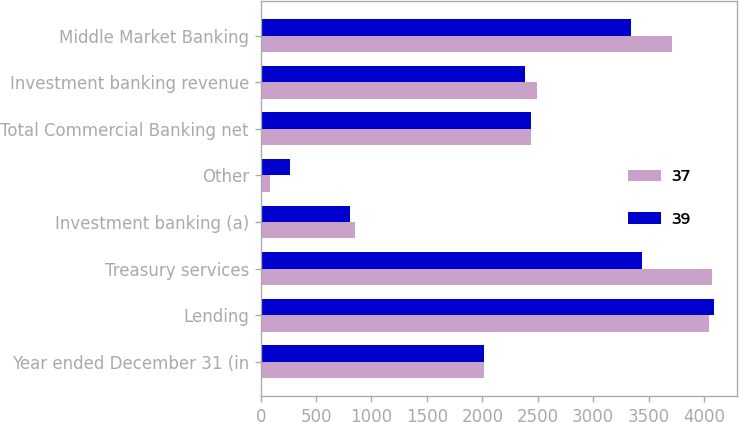<chart> <loc_0><loc_0><loc_500><loc_500><stacked_bar_chart><ecel><fcel>Year ended December 31 (in<fcel>Lending<fcel>Treasury services<fcel>Investment banking (a)<fcel>Other<fcel>Total Commercial Banking net<fcel>Investment banking revenue<fcel>Middle Market Banking<nl><fcel>37<fcel>2018<fcel>4049<fcel>4074<fcel>852<fcel>84<fcel>2438<fcel>2491<fcel>3708<nl><fcel>39<fcel>2017<fcel>4094<fcel>3444<fcel>805<fcel>262<fcel>2438<fcel>2385<fcel>3341<nl></chart> 